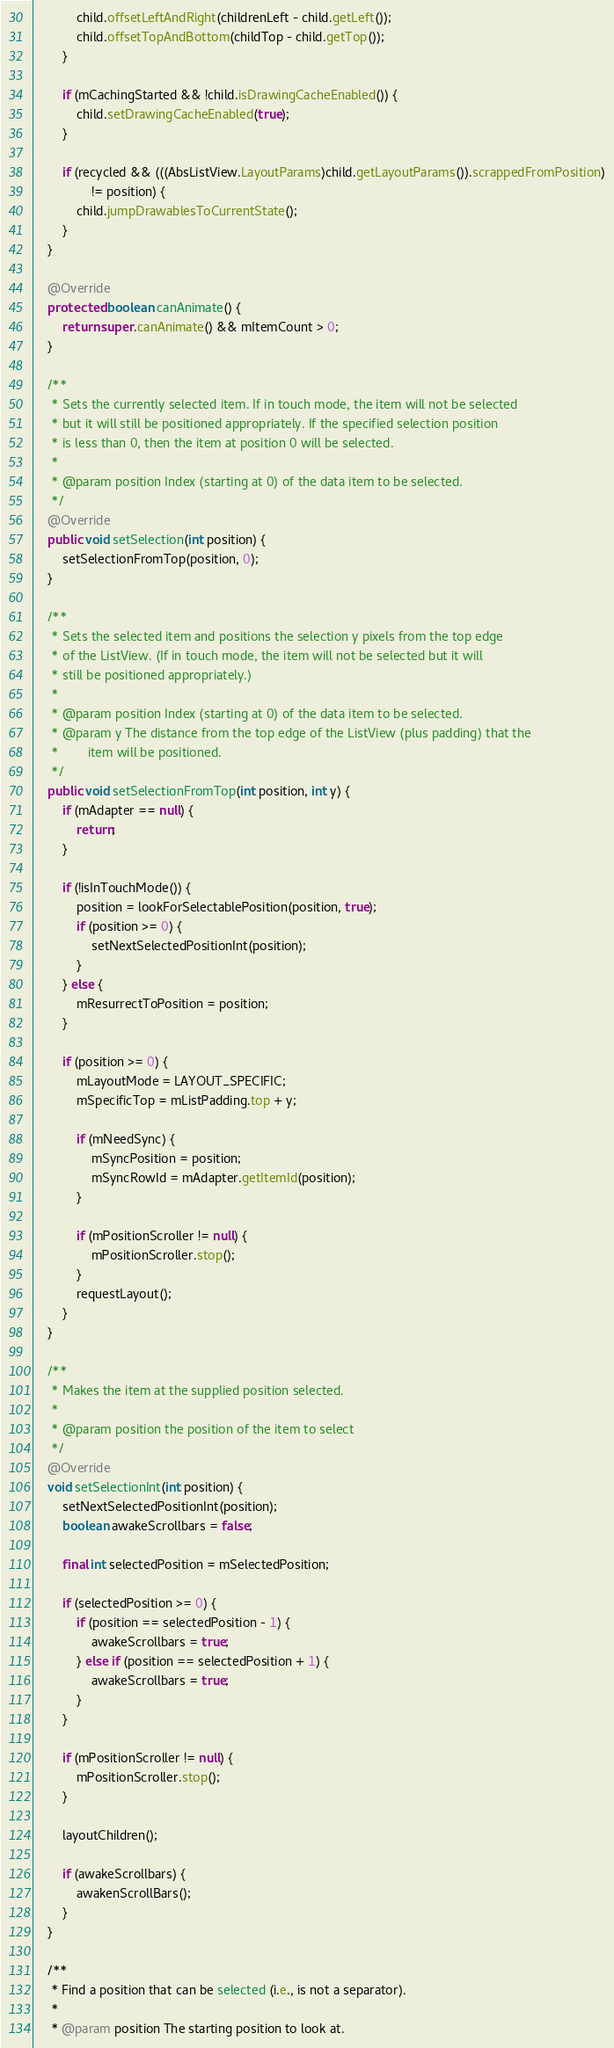<code> <loc_0><loc_0><loc_500><loc_500><_Java_>            child.offsetLeftAndRight(childrenLeft - child.getLeft());
            child.offsetTopAndBottom(childTop - child.getTop());
        }

        if (mCachingStarted && !child.isDrawingCacheEnabled()) {
            child.setDrawingCacheEnabled(true);
        }

        if (recycled && (((AbsListView.LayoutParams)child.getLayoutParams()).scrappedFromPosition)
                != position) {
            child.jumpDrawablesToCurrentState();
        }
    }

    @Override
    protected boolean canAnimate() {
        return super.canAnimate() && mItemCount > 0;
    }

    /**
     * Sets the currently selected item. If in touch mode, the item will not be selected
     * but it will still be positioned appropriately. If the specified selection position
     * is less than 0, then the item at position 0 will be selected.
     *
     * @param position Index (starting at 0) of the data item to be selected.
     */
    @Override
    public void setSelection(int position) {
        setSelectionFromTop(position, 0);
    }

    /**
     * Sets the selected item and positions the selection y pixels from the top edge
     * of the ListView. (If in touch mode, the item will not be selected but it will
     * still be positioned appropriately.)
     *
     * @param position Index (starting at 0) of the data item to be selected.
     * @param y The distance from the top edge of the ListView (plus padding) that the
     *        item will be positioned.
     */
    public void setSelectionFromTop(int position, int y) {
        if (mAdapter == null) {
            return;
        }

        if (!isInTouchMode()) {
            position = lookForSelectablePosition(position, true);
            if (position >= 0) {
                setNextSelectedPositionInt(position);
            }
        } else {
            mResurrectToPosition = position;
        }

        if (position >= 0) {
            mLayoutMode = LAYOUT_SPECIFIC;
            mSpecificTop = mListPadding.top + y;

            if (mNeedSync) {
                mSyncPosition = position;
                mSyncRowId = mAdapter.getItemId(position);
            }

            if (mPositionScroller != null) {
                mPositionScroller.stop();
            }
            requestLayout();
        }
    }

    /**
     * Makes the item at the supplied position selected.
     * 
     * @param position the position of the item to select
     */
    @Override
    void setSelectionInt(int position) {
        setNextSelectedPositionInt(position);
        boolean awakeScrollbars = false;

        final int selectedPosition = mSelectedPosition;

        if (selectedPosition >= 0) {
            if (position == selectedPosition - 1) {
                awakeScrollbars = true;
            } else if (position == selectedPosition + 1) {
                awakeScrollbars = true;
            }
        }

        if (mPositionScroller != null) {
            mPositionScroller.stop();
        }

        layoutChildren();

        if (awakeScrollbars) {
            awakenScrollBars();
        }
    }

    /**
     * Find a position that can be selected (i.e., is not a separator).
     *
     * @param position The starting position to look at.</code> 